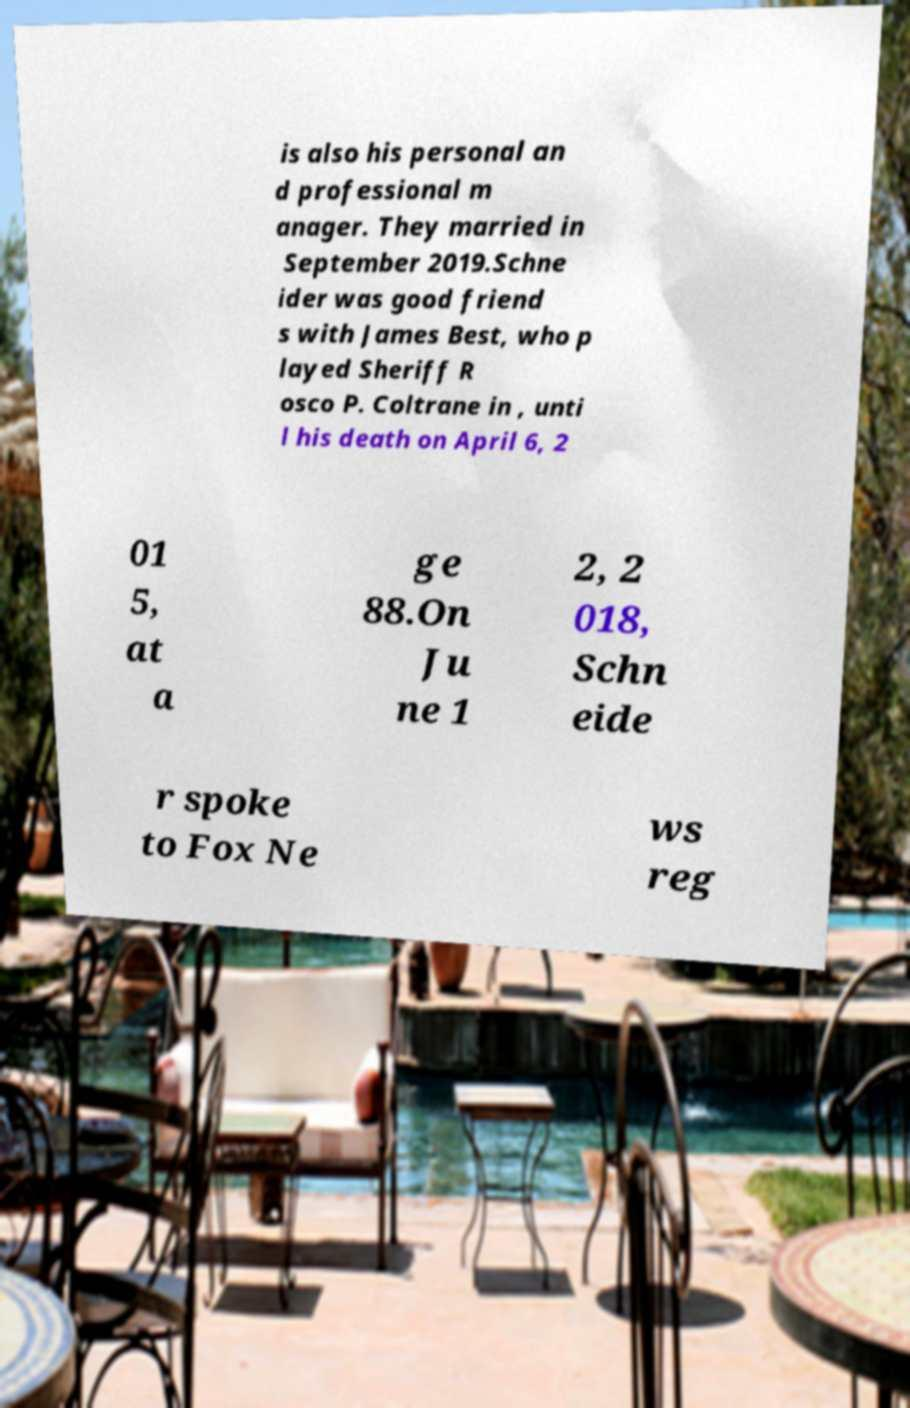Please read and relay the text visible in this image. What does it say? is also his personal an d professional m anager. They married in September 2019.Schne ider was good friend s with James Best, who p layed Sheriff R osco P. Coltrane in , unti l his death on April 6, 2 01 5, at a ge 88.On Ju ne 1 2, 2 018, Schn eide r spoke to Fox Ne ws reg 